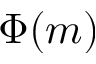<formula> <loc_0><loc_0><loc_500><loc_500>\Phi ( m )</formula> 